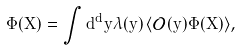<formula> <loc_0><loc_0><loc_500><loc_500>\Phi ( X ) = \int d ^ { d } y \lambda ( y ) \, \langle \mathcal { O } ( y ) \hat { \Phi } ( X ) \rangle ,</formula> 